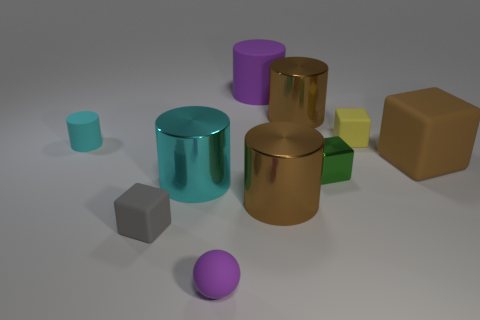Subtract 1 cubes. How many cubes are left? 3 Subtract all small cyan matte cylinders. How many cylinders are left? 4 Subtract all purple cylinders. How many cylinders are left? 4 Subtract all yellow cylinders. Subtract all gray balls. How many cylinders are left? 5 Subtract all balls. How many objects are left? 9 Add 3 brown cylinders. How many brown cylinders exist? 5 Subtract 1 cyan cylinders. How many objects are left? 9 Subtract all big purple metal cylinders. Subtract all small rubber balls. How many objects are left? 9 Add 2 rubber cylinders. How many rubber cylinders are left? 4 